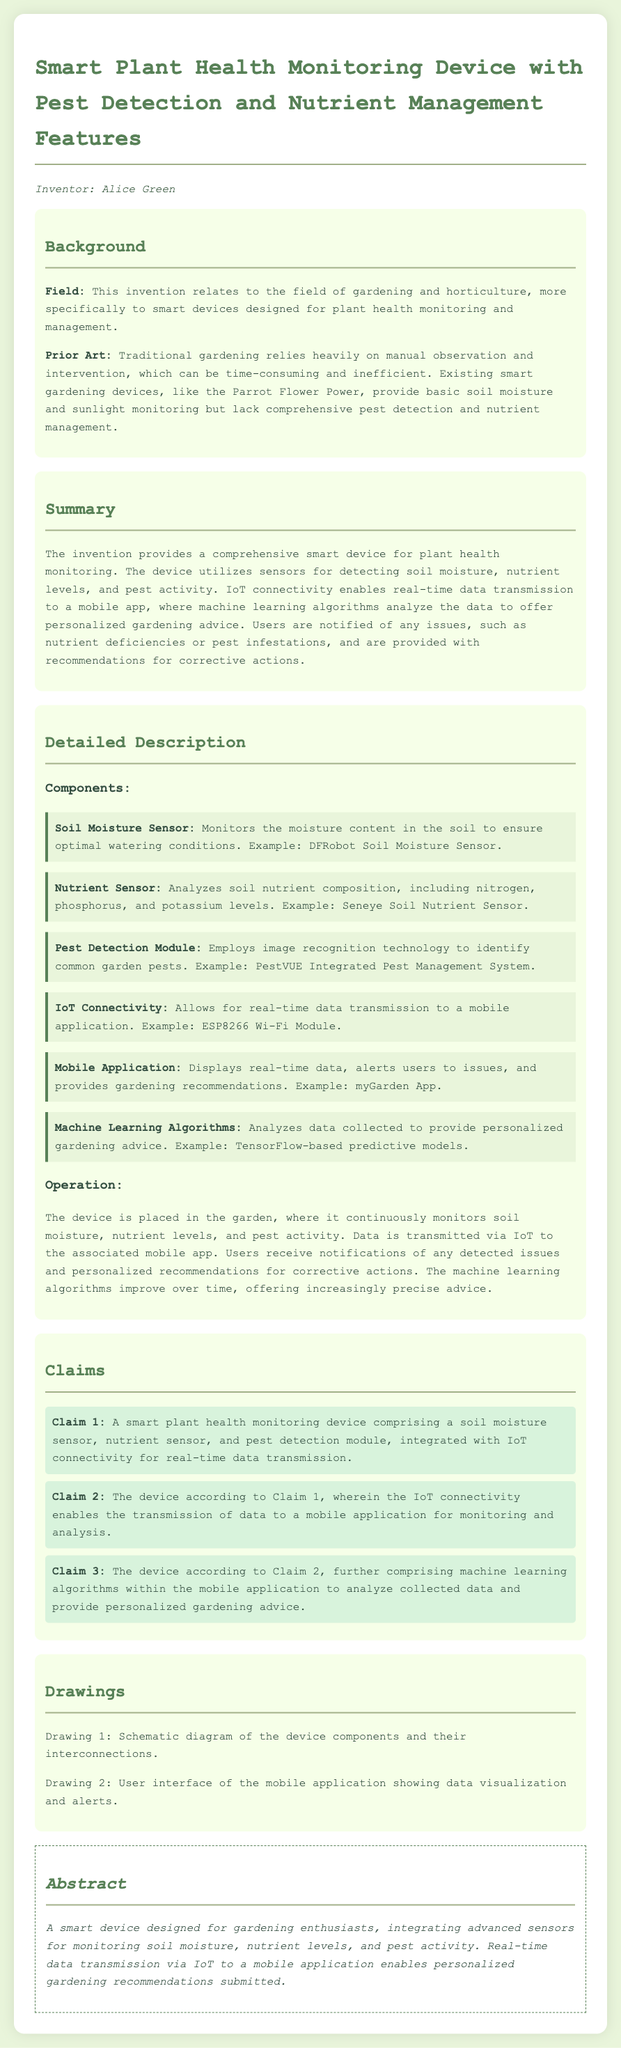What is the name of the inventor? The inventor of the device is mentioned in the document as Alice Green.
Answer: Alice Green What does the device monitor in the garden? The document states that the device monitors soil moisture, nutrient levels, and pest activity.
Answer: Soil moisture, nutrient levels, and pest activity Which component analyzes soil nutrient composition? The document specifies that the Nutrient Sensor analyzes soil nutrient composition, including nitrogen, phosphorus, and potassium levels.
Answer: Nutrient Sensor What does IoT stand for? The document refers to IoT as the technology that enables real-time data transmission to a mobile application.
Answer: Internet of Things How many claims are listed in the document? The document lists a total of three claims regarding the smart device's features and functionalities.
Answer: Three What type of algorithms does the mobile application use? The document mentions that the mobile application utilizes machine learning algorithms to analyze the collected data.
Answer: Machine learning algorithms In what field does this invention primarily belong? The document indicates that the invention relates to the field of gardening and horticulture.
Answer: Gardening and horticulture What is provided to users when issues are detected? The device provides users with recommendations for corrective actions when issues such as nutrient deficiencies or pest infestations are detected.
Answer: Recommendations for corrective actions 